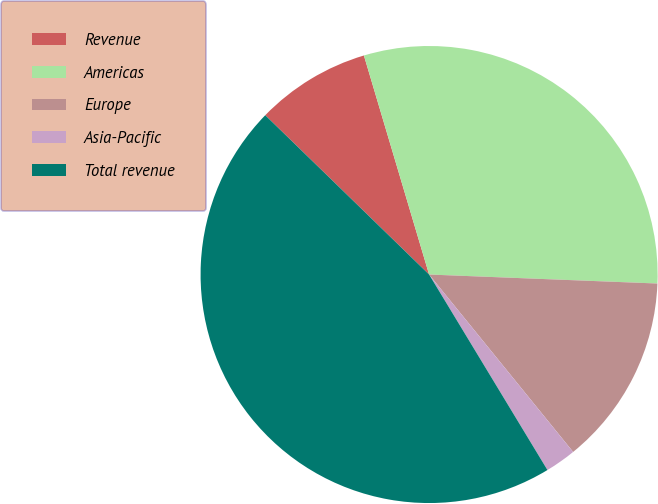Convert chart. <chart><loc_0><loc_0><loc_500><loc_500><pie_chart><fcel>Revenue<fcel>Americas<fcel>Europe<fcel>Asia-Pacific<fcel>Total revenue<nl><fcel>8.12%<fcel>30.23%<fcel>13.52%<fcel>2.19%<fcel>45.94%<nl></chart> 